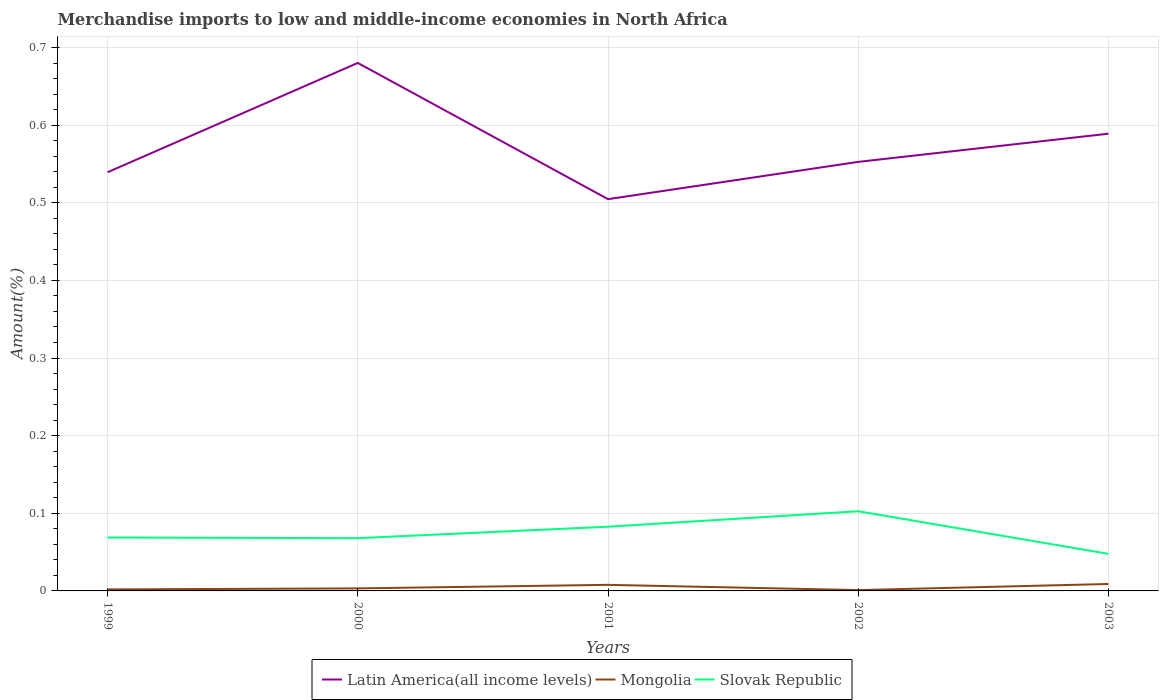How many different coloured lines are there?
Provide a short and direct response. 3. Is the number of lines equal to the number of legend labels?
Ensure brevity in your answer.  Yes. Across all years, what is the maximum percentage of amount earned from merchandise imports in Mongolia?
Your answer should be very brief. 0. What is the total percentage of amount earned from merchandise imports in Slovak Republic in the graph?
Provide a succinct answer. -0.01. What is the difference between the highest and the second highest percentage of amount earned from merchandise imports in Slovak Republic?
Keep it short and to the point. 0.05. Is the percentage of amount earned from merchandise imports in Latin America(all income levels) strictly greater than the percentage of amount earned from merchandise imports in Mongolia over the years?
Offer a terse response. No. How many lines are there?
Make the answer very short. 3. Are the values on the major ticks of Y-axis written in scientific E-notation?
Ensure brevity in your answer.  No. Does the graph contain any zero values?
Keep it short and to the point. No. Does the graph contain grids?
Your answer should be very brief. Yes. Where does the legend appear in the graph?
Give a very brief answer. Bottom center. How many legend labels are there?
Your answer should be compact. 3. How are the legend labels stacked?
Your answer should be compact. Horizontal. What is the title of the graph?
Ensure brevity in your answer.  Merchandise imports to low and middle-income economies in North Africa. Does "Malawi" appear as one of the legend labels in the graph?
Your response must be concise. No. What is the label or title of the Y-axis?
Make the answer very short. Amount(%). What is the Amount(%) of Latin America(all income levels) in 1999?
Offer a terse response. 0.54. What is the Amount(%) of Mongolia in 1999?
Ensure brevity in your answer.  0. What is the Amount(%) in Slovak Republic in 1999?
Ensure brevity in your answer.  0.07. What is the Amount(%) in Latin America(all income levels) in 2000?
Provide a succinct answer. 0.68. What is the Amount(%) in Mongolia in 2000?
Offer a terse response. 0. What is the Amount(%) of Slovak Republic in 2000?
Keep it short and to the point. 0.07. What is the Amount(%) of Latin America(all income levels) in 2001?
Provide a succinct answer. 0.5. What is the Amount(%) in Mongolia in 2001?
Your response must be concise. 0.01. What is the Amount(%) in Slovak Republic in 2001?
Keep it short and to the point. 0.08. What is the Amount(%) of Latin America(all income levels) in 2002?
Ensure brevity in your answer.  0.55. What is the Amount(%) in Mongolia in 2002?
Your answer should be compact. 0. What is the Amount(%) of Slovak Republic in 2002?
Provide a short and direct response. 0.1. What is the Amount(%) of Latin America(all income levels) in 2003?
Give a very brief answer. 0.59. What is the Amount(%) in Mongolia in 2003?
Your answer should be very brief. 0.01. What is the Amount(%) in Slovak Republic in 2003?
Provide a short and direct response. 0.05. Across all years, what is the maximum Amount(%) in Latin America(all income levels)?
Offer a terse response. 0.68. Across all years, what is the maximum Amount(%) in Mongolia?
Give a very brief answer. 0.01. Across all years, what is the maximum Amount(%) in Slovak Republic?
Offer a very short reply. 0.1. Across all years, what is the minimum Amount(%) of Latin America(all income levels)?
Provide a short and direct response. 0.5. Across all years, what is the minimum Amount(%) of Mongolia?
Offer a terse response. 0. Across all years, what is the minimum Amount(%) in Slovak Republic?
Make the answer very short. 0.05. What is the total Amount(%) in Latin America(all income levels) in the graph?
Give a very brief answer. 2.87. What is the total Amount(%) of Mongolia in the graph?
Provide a short and direct response. 0.02. What is the total Amount(%) of Slovak Republic in the graph?
Provide a succinct answer. 0.37. What is the difference between the Amount(%) of Latin America(all income levels) in 1999 and that in 2000?
Provide a short and direct response. -0.14. What is the difference between the Amount(%) in Mongolia in 1999 and that in 2000?
Provide a succinct answer. -0. What is the difference between the Amount(%) of Slovak Republic in 1999 and that in 2000?
Your answer should be compact. 0. What is the difference between the Amount(%) in Latin America(all income levels) in 1999 and that in 2001?
Provide a short and direct response. 0.03. What is the difference between the Amount(%) of Mongolia in 1999 and that in 2001?
Make the answer very short. -0.01. What is the difference between the Amount(%) of Slovak Republic in 1999 and that in 2001?
Your response must be concise. -0.01. What is the difference between the Amount(%) of Latin America(all income levels) in 1999 and that in 2002?
Offer a very short reply. -0.01. What is the difference between the Amount(%) in Mongolia in 1999 and that in 2002?
Offer a terse response. 0. What is the difference between the Amount(%) of Slovak Republic in 1999 and that in 2002?
Offer a very short reply. -0.03. What is the difference between the Amount(%) in Latin America(all income levels) in 1999 and that in 2003?
Give a very brief answer. -0.05. What is the difference between the Amount(%) of Mongolia in 1999 and that in 2003?
Ensure brevity in your answer.  -0.01. What is the difference between the Amount(%) in Slovak Republic in 1999 and that in 2003?
Provide a succinct answer. 0.02. What is the difference between the Amount(%) in Latin America(all income levels) in 2000 and that in 2001?
Your answer should be very brief. 0.18. What is the difference between the Amount(%) of Mongolia in 2000 and that in 2001?
Ensure brevity in your answer.  -0. What is the difference between the Amount(%) in Slovak Republic in 2000 and that in 2001?
Make the answer very short. -0.01. What is the difference between the Amount(%) in Latin America(all income levels) in 2000 and that in 2002?
Provide a succinct answer. 0.13. What is the difference between the Amount(%) of Mongolia in 2000 and that in 2002?
Offer a very short reply. 0. What is the difference between the Amount(%) in Slovak Republic in 2000 and that in 2002?
Your answer should be very brief. -0.03. What is the difference between the Amount(%) in Latin America(all income levels) in 2000 and that in 2003?
Provide a short and direct response. 0.09. What is the difference between the Amount(%) of Mongolia in 2000 and that in 2003?
Provide a succinct answer. -0.01. What is the difference between the Amount(%) in Slovak Republic in 2000 and that in 2003?
Your answer should be compact. 0.02. What is the difference between the Amount(%) in Latin America(all income levels) in 2001 and that in 2002?
Keep it short and to the point. -0.05. What is the difference between the Amount(%) in Mongolia in 2001 and that in 2002?
Provide a succinct answer. 0.01. What is the difference between the Amount(%) in Slovak Republic in 2001 and that in 2002?
Provide a succinct answer. -0.02. What is the difference between the Amount(%) of Latin America(all income levels) in 2001 and that in 2003?
Your answer should be compact. -0.08. What is the difference between the Amount(%) in Mongolia in 2001 and that in 2003?
Your answer should be compact. -0. What is the difference between the Amount(%) in Slovak Republic in 2001 and that in 2003?
Offer a very short reply. 0.04. What is the difference between the Amount(%) of Latin America(all income levels) in 2002 and that in 2003?
Keep it short and to the point. -0.04. What is the difference between the Amount(%) of Mongolia in 2002 and that in 2003?
Make the answer very short. -0.01. What is the difference between the Amount(%) of Slovak Republic in 2002 and that in 2003?
Give a very brief answer. 0.05. What is the difference between the Amount(%) in Latin America(all income levels) in 1999 and the Amount(%) in Mongolia in 2000?
Your response must be concise. 0.54. What is the difference between the Amount(%) in Latin America(all income levels) in 1999 and the Amount(%) in Slovak Republic in 2000?
Provide a succinct answer. 0.47. What is the difference between the Amount(%) of Mongolia in 1999 and the Amount(%) of Slovak Republic in 2000?
Make the answer very short. -0.07. What is the difference between the Amount(%) of Latin America(all income levels) in 1999 and the Amount(%) of Mongolia in 2001?
Make the answer very short. 0.53. What is the difference between the Amount(%) in Latin America(all income levels) in 1999 and the Amount(%) in Slovak Republic in 2001?
Keep it short and to the point. 0.46. What is the difference between the Amount(%) in Mongolia in 1999 and the Amount(%) in Slovak Republic in 2001?
Offer a terse response. -0.08. What is the difference between the Amount(%) in Latin America(all income levels) in 1999 and the Amount(%) in Mongolia in 2002?
Your response must be concise. 0.54. What is the difference between the Amount(%) of Latin America(all income levels) in 1999 and the Amount(%) of Slovak Republic in 2002?
Your answer should be very brief. 0.44. What is the difference between the Amount(%) in Mongolia in 1999 and the Amount(%) in Slovak Republic in 2002?
Your answer should be compact. -0.1. What is the difference between the Amount(%) in Latin America(all income levels) in 1999 and the Amount(%) in Mongolia in 2003?
Offer a very short reply. 0.53. What is the difference between the Amount(%) in Latin America(all income levels) in 1999 and the Amount(%) in Slovak Republic in 2003?
Ensure brevity in your answer.  0.49. What is the difference between the Amount(%) in Mongolia in 1999 and the Amount(%) in Slovak Republic in 2003?
Offer a very short reply. -0.05. What is the difference between the Amount(%) in Latin America(all income levels) in 2000 and the Amount(%) in Mongolia in 2001?
Ensure brevity in your answer.  0.67. What is the difference between the Amount(%) of Latin America(all income levels) in 2000 and the Amount(%) of Slovak Republic in 2001?
Offer a very short reply. 0.6. What is the difference between the Amount(%) in Mongolia in 2000 and the Amount(%) in Slovak Republic in 2001?
Keep it short and to the point. -0.08. What is the difference between the Amount(%) in Latin America(all income levels) in 2000 and the Amount(%) in Mongolia in 2002?
Offer a very short reply. 0.68. What is the difference between the Amount(%) of Latin America(all income levels) in 2000 and the Amount(%) of Slovak Republic in 2002?
Offer a very short reply. 0.58. What is the difference between the Amount(%) in Mongolia in 2000 and the Amount(%) in Slovak Republic in 2002?
Keep it short and to the point. -0.1. What is the difference between the Amount(%) in Latin America(all income levels) in 2000 and the Amount(%) in Mongolia in 2003?
Your response must be concise. 0.67. What is the difference between the Amount(%) in Latin America(all income levels) in 2000 and the Amount(%) in Slovak Republic in 2003?
Make the answer very short. 0.63. What is the difference between the Amount(%) in Mongolia in 2000 and the Amount(%) in Slovak Republic in 2003?
Make the answer very short. -0.04. What is the difference between the Amount(%) in Latin America(all income levels) in 2001 and the Amount(%) in Mongolia in 2002?
Offer a very short reply. 0.5. What is the difference between the Amount(%) of Latin America(all income levels) in 2001 and the Amount(%) of Slovak Republic in 2002?
Make the answer very short. 0.4. What is the difference between the Amount(%) in Mongolia in 2001 and the Amount(%) in Slovak Republic in 2002?
Offer a very short reply. -0.09. What is the difference between the Amount(%) of Latin America(all income levels) in 2001 and the Amount(%) of Mongolia in 2003?
Your answer should be compact. 0.5. What is the difference between the Amount(%) in Latin America(all income levels) in 2001 and the Amount(%) in Slovak Republic in 2003?
Provide a short and direct response. 0.46. What is the difference between the Amount(%) of Mongolia in 2001 and the Amount(%) of Slovak Republic in 2003?
Make the answer very short. -0.04. What is the difference between the Amount(%) in Latin America(all income levels) in 2002 and the Amount(%) in Mongolia in 2003?
Your answer should be compact. 0.54. What is the difference between the Amount(%) in Latin America(all income levels) in 2002 and the Amount(%) in Slovak Republic in 2003?
Give a very brief answer. 0.5. What is the difference between the Amount(%) of Mongolia in 2002 and the Amount(%) of Slovak Republic in 2003?
Make the answer very short. -0.05. What is the average Amount(%) of Latin America(all income levels) per year?
Give a very brief answer. 0.57. What is the average Amount(%) in Mongolia per year?
Give a very brief answer. 0. What is the average Amount(%) of Slovak Republic per year?
Offer a terse response. 0.07. In the year 1999, what is the difference between the Amount(%) in Latin America(all income levels) and Amount(%) in Mongolia?
Provide a succinct answer. 0.54. In the year 1999, what is the difference between the Amount(%) in Latin America(all income levels) and Amount(%) in Slovak Republic?
Provide a short and direct response. 0.47. In the year 1999, what is the difference between the Amount(%) of Mongolia and Amount(%) of Slovak Republic?
Provide a succinct answer. -0.07. In the year 2000, what is the difference between the Amount(%) of Latin America(all income levels) and Amount(%) of Mongolia?
Keep it short and to the point. 0.68. In the year 2000, what is the difference between the Amount(%) of Latin America(all income levels) and Amount(%) of Slovak Republic?
Keep it short and to the point. 0.61. In the year 2000, what is the difference between the Amount(%) in Mongolia and Amount(%) in Slovak Republic?
Give a very brief answer. -0.06. In the year 2001, what is the difference between the Amount(%) in Latin America(all income levels) and Amount(%) in Mongolia?
Offer a terse response. 0.5. In the year 2001, what is the difference between the Amount(%) in Latin America(all income levels) and Amount(%) in Slovak Republic?
Your answer should be compact. 0.42. In the year 2001, what is the difference between the Amount(%) of Mongolia and Amount(%) of Slovak Republic?
Give a very brief answer. -0.07. In the year 2002, what is the difference between the Amount(%) in Latin America(all income levels) and Amount(%) in Mongolia?
Give a very brief answer. 0.55. In the year 2002, what is the difference between the Amount(%) of Latin America(all income levels) and Amount(%) of Slovak Republic?
Ensure brevity in your answer.  0.45. In the year 2002, what is the difference between the Amount(%) of Mongolia and Amount(%) of Slovak Republic?
Keep it short and to the point. -0.1. In the year 2003, what is the difference between the Amount(%) in Latin America(all income levels) and Amount(%) in Mongolia?
Provide a short and direct response. 0.58. In the year 2003, what is the difference between the Amount(%) in Latin America(all income levels) and Amount(%) in Slovak Republic?
Your response must be concise. 0.54. In the year 2003, what is the difference between the Amount(%) in Mongolia and Amount(%) in Slovak Republic?
Keep it short and to the point. -0.04. What is the ratio of the Amount(%) in Latin America(all income levels) in 1999 to that in 2000?
Offer a terse response. 0.79. What is the ratio of the Amount(%) of Mongolia in 1999 to that in 2000?
Ensure brevity in your answer.  0.6. What is the ratio of the Amount(%) of Slovak Republic in 1999 to that in 2000?
Offer a very short reply. 1.01. What is the ratio of the Amount(%) in Latin America(all income levels) in 1999 to that in 2001?
Ensure brevity in your answer.  1.07. What is the ratio of the Amount(%) of Mongolia in 1999 to that in 2001?
Provide a succinct answer. 0.25. What is the ratio of the Amount(%) in Slovak Republic in 1999 to that in 2001?
Give a very brief answer. 0.83. What is the ratio of the Amount(%) in Latin America(all income levels) in 1999 to that in 2002?
Offer a terse response. 0.98. What is the ratio of the Amount(%) of Mongolia in 1999 to that in 2002?
Make the answer very short. 1.82. What is the ratio of the Amount(%) in Slovak Republic in 1999 to that in 2002?
Your answer should be compact. 0.67. What is the ratio of the Amount(%) of Latin America(all income levels) in 1999 to that in 2003?
Offer a very short reply. 0.92. What is the ratio of the Amount(%) in Mongolia in 1999 to that in 2003?
Provide a short and direct response. 0.22. What is the ratio of the Amount(%) in Slovak Republic in 1999 to that in 2003?
Offer a terse response. 1.44. What is the ratio of the Amount(%) of Latin America(all income levels) in 2000 to that in 2001?
Keep it short and to the point. 1.35. What is the ratio of the Amount(%) of Mongolia in 2000 to that in 2001?
Provide a short and direct response. 0.42. What is the ratio of the Amount(%) in Slovak Republic in 2000 to that in 2001?
Give a very brief answer. 0.82. What is the ratio of the Amount(%) of Latin America(all income levels) in 2000 to that in 2002?
Your answer should be very brief. 1.23. What is the ratio of the Amount(%) of Mongolia in 2000 to that in 2002?
Provide a succinct answer. 3.04. What is the ratio of the Amount(%) of Slovak Republic in 2000 to that in 2002?
Offer a terse response. 0.66. What is the ratio of the Amount(%) of Latin America(all income levels) in 2000 to that in 2003?
Your response must be concise. 1.15. What is the ratio of the Amount(%) of Mongolia in 2000 to that in 2003?
Your answer should be compact. 0.36. What is the ratio of the Amount(%) of Slovak Republic in 2000 to that in 2003?
Your response must be concise. 1.42. What is the ratio of the Amount(%) of Latin America(all income levels) in 2001 to that in 2002?
Ensure brevity in your answer.  0.91. What is the ratio of the Amount(%) in Mongolia in 2001 to that in 2002?
Your response must be concise. 7.3. What is the ratio of the Amount(%) in Slovak Republic in 2001 to that in 2002?
Provide a short and direct response. 0.81. What is the ratio of the Amount(%) of Latin America(all income levels) in 2001 to that in 2003?
Your answer should be very brief. 0.86. What is the ratio of the Amount(%) of Mongolia in 2001 to that in 2003?
Keep it short and to the point. 0.88. What is the ratio of the Amount(%) in Slovak Republic in 2001 to that in 2003?
Keep it short and to the point. 1.73. What is the ratio of the Amount(%) in Latin America(all income levels) in 2002 to that in 2003?
Provide a short and direct response. 0.94. What is the ratio of the Amount(%) of Mongolia in 2002 to that in 2003?
Ensure brevity in your answer.  0.12. What is the ratio of the Amount(%) in Slovak Republic in 2002 to that in 2003?
Provide a short and direct response. 2.15. What is the difference between the highest and the second highest Amount(%) of Latin America(all income levels)?
Your response must be concise. 0.09. What is the difference between the highest and the second highest Amount(%) in Mongolia?
Make the answer very short. 0. What is the difference between the highest and the second highest Amount(%) in Slovak Republic?
Ensure brevity in your answer.  0.02. What is the difference between the highest and the lowest Amount(%) in Latin America(all income levels)?
Your response must be concise. 0.18. What is the difference between the highest and the lowest Amount(%) in Mongolia?
Make the answer very short. 0.01. What is the difference between the highest and the lowest Amount(%) of Slovak Republic?
Offer a very short reply. 0.05. 